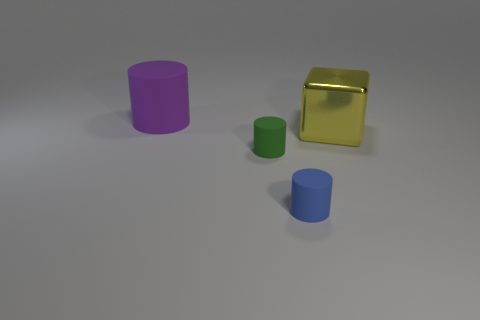Subtract all tiny green cylinders. How many cylinders are left? 2 Subtract all purple cylinders. How many cylinders are left? 2 Add 1 brown blocks. How many objects exist? 5 Subtract all cylinders. How many objects are left? 1 Subtract all blue cylinders. Subtract all yellow blocks. How many cylinders are left? 2 Subtract all gray balls. How many blue cylinders are left? 1 Subtract all yellow matte cylinders. Subtract all yellow shiny objects. How many objects are left? 3 Add 2 purple rubber objects. How many purple rubber objects are left? 3 Add 3 cubes. How many cubes exist? 4 Subtract 1 yellow cubes. How many objects are left? 3 